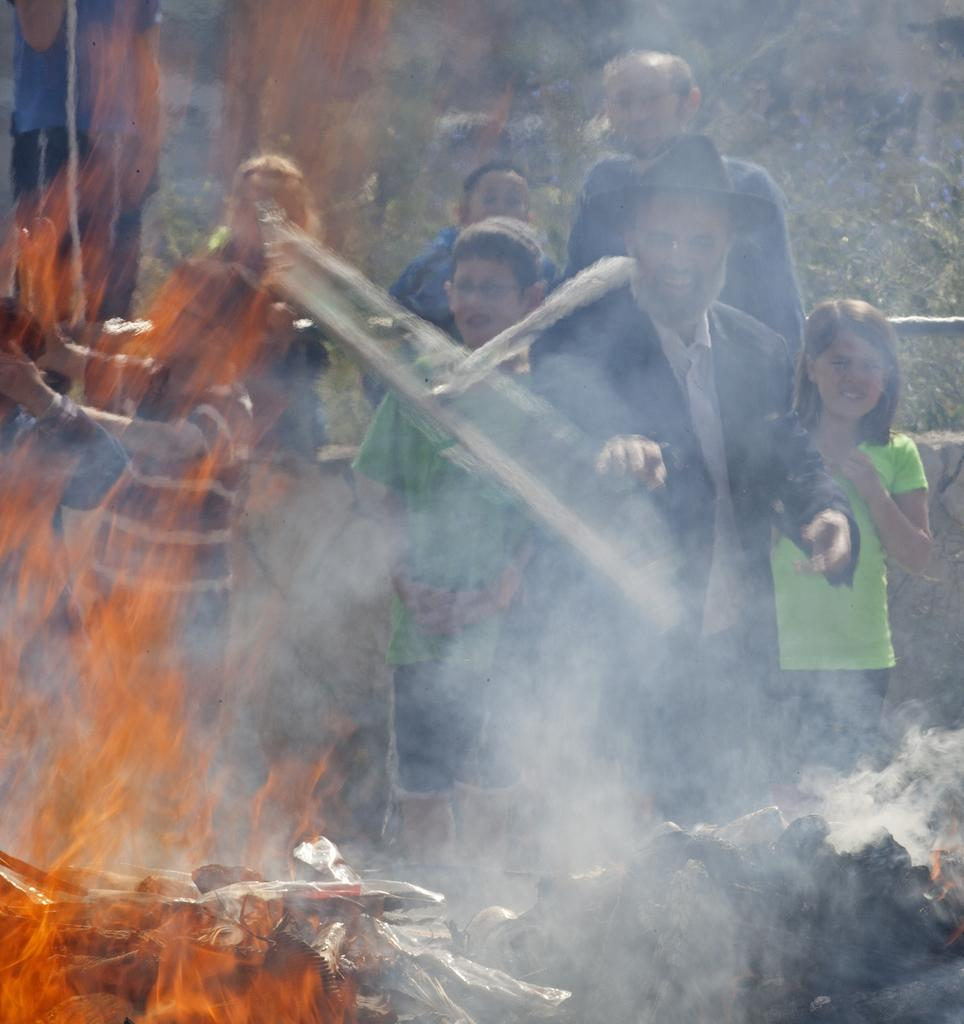What can be seen on the left side of the image? There is fire on the left side of the image. What is located on the right side of the image? There are people on the right side of the image. What type of pin can be seen in the image? There is no pin present in the image. What is inside the sack that the people are holding in the image? There is no sack or any items being held by the people in the image. 